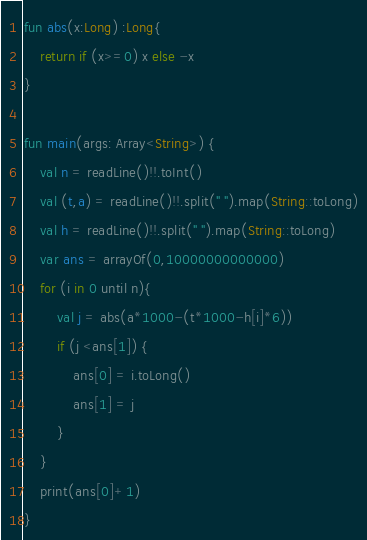<code> <loc_0><loc_0><loc_500><loc_500><_Kotlin_>fun abs(x:Long) :Long{
    return if (x>=0) x else -x
}

fun main(args: Array<String>) {
    val n = readLine()!!.toInt()
    val (t,a) = readLine()!!.split(" ").map(String::toLong)
    val h = readLine()!!.split(" ").map(String::toLong)
    var ans = arrayOf(0,10000000000000)
    for (i in 0 until n){
        val j = abs(a*1000-(t*1000-h[i]*6))
        if (j <ans[1]) {
            ans[0] = i.toLong()
            ans[1] = j
        }
    }
    print(ans[0]+1)
}</code> 